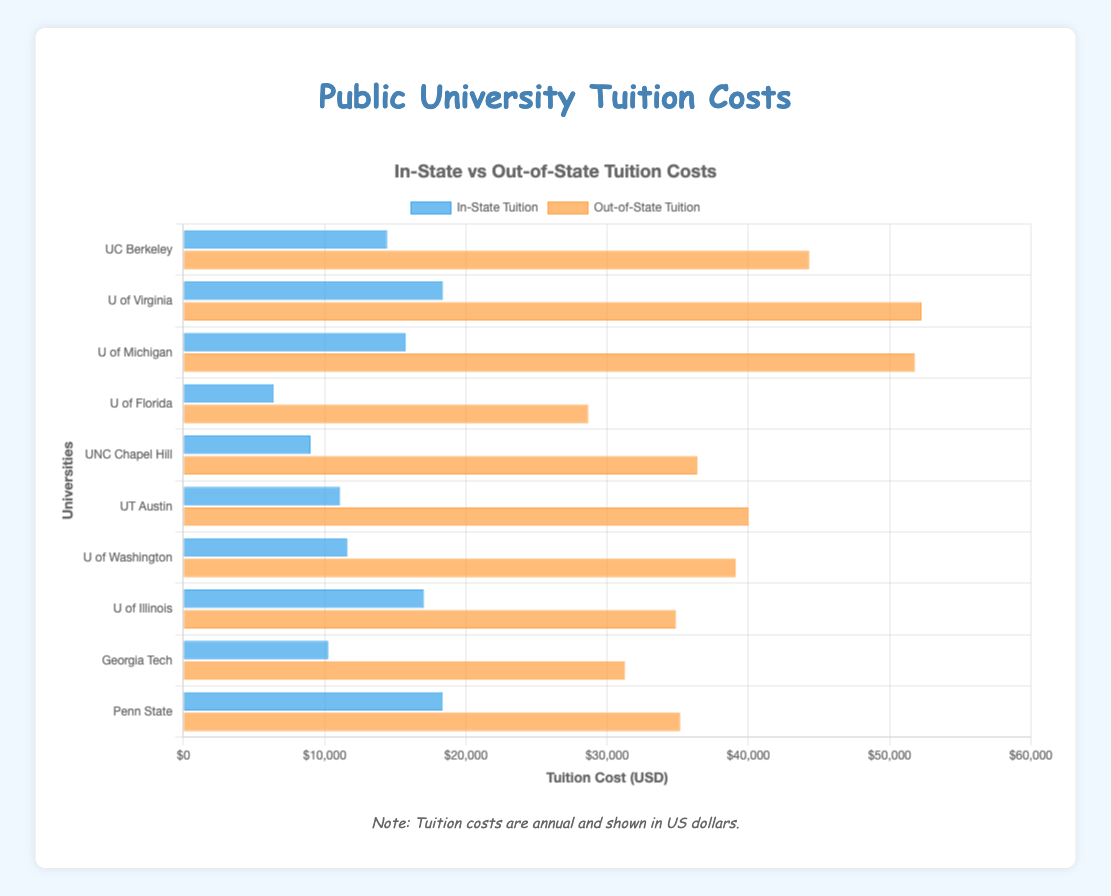Which university has the highest in-state tuition? The bar that represents in-state tuition is highest for the University of Virginia among all listed universities.
Answer: University of Virginia What is the difference in out-of-state tuition between the University of California, Berkeley, and the University of Michigan, Ann Arbor? The out-of-state tuition for UC Berkeley is $44,308, and for the University of Michigan, it is $51,796. The difference is $51,796 - $44,308.
Answer: $7,488 Which university has the smallest difference between in-state and out-of-state tuition? By comparing all the bars for each university, the University of Florida has the smallest difference between its in-state tuition ($6,390) and out-of-state tuition ($28,658).
Answer: University of Florida What is the visual difference between in-state and out-of-state tuition costs in the chart? The in-state tuition bars are represented in blue, while the out-of-state tuition bars are in orange.
Answer: Blue and Orange How much more is the average out-of-state tuition compared to in-state tuition across all universities? Sum all in-state and out-of-state tuition values, divide each sum by the number of universities to get the averages, and then find the difference. \((\frac{14426+18378+15748+6390+8998+11092+11605+17034+10258+18354}{10} = 13288.3\)) and \((\frac{44308+52264+51796+28658+36390+40032+39114+34877+31270+35174}{10} = 39388.3\)). Difference is \(39388.3 - 13288.3\).
Answer: $26,100 Which university has the highest out-of-state tuition? The University of Virginia has the highest out-of-state tuition among the universities listed, with $52,264.
Answer: University of Virginia How many universities have an in-state tuition cost less than $15,000? By counting the blue bars representing in-state tuition costs that are less than $15,000, there are seven universities: UC Berkeley, University of Michigan, University of Florida, UNC Chapel Hill, UT Austin, University of Washington, and Georgia Tech.
Answer: Seven Which universities have a greater out-of-state tuition than the average out-of-state tuition of all universities shown? First, calculate the average out-of-state tuition. Sum all out-of-state tuition values and divide by the number of universities: \((44308+52264+51796+28658+36390+40032+39114+34877+31270+35174) / 10\ = 39388.3\). Then compare individual out-of-state tuition to this average. Students with tuition higher than $39,388: University of Virginia and University of Michigan.
Answer: University of Virginia, University of Michigan 